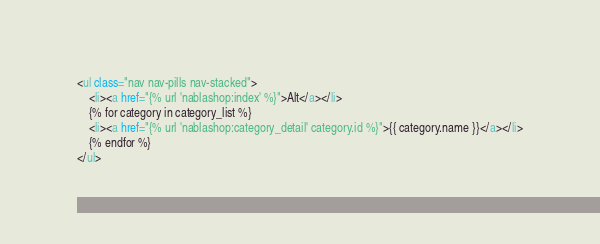Convert code to text. <code><loc_0><loc_0><loc_500><loc_500><_HTML_><ul class="nav nav-pills nav-stacked">
    <li><a href="{% url 'nablashop:index' %}">Alt</a></li>
    {% for category in category_list %}
    <li><a href="{% url 'nablashop:category_detail' category.id %}">{{ category.name }}</a></li>
    {% endfor %}
</ul>

</code> 